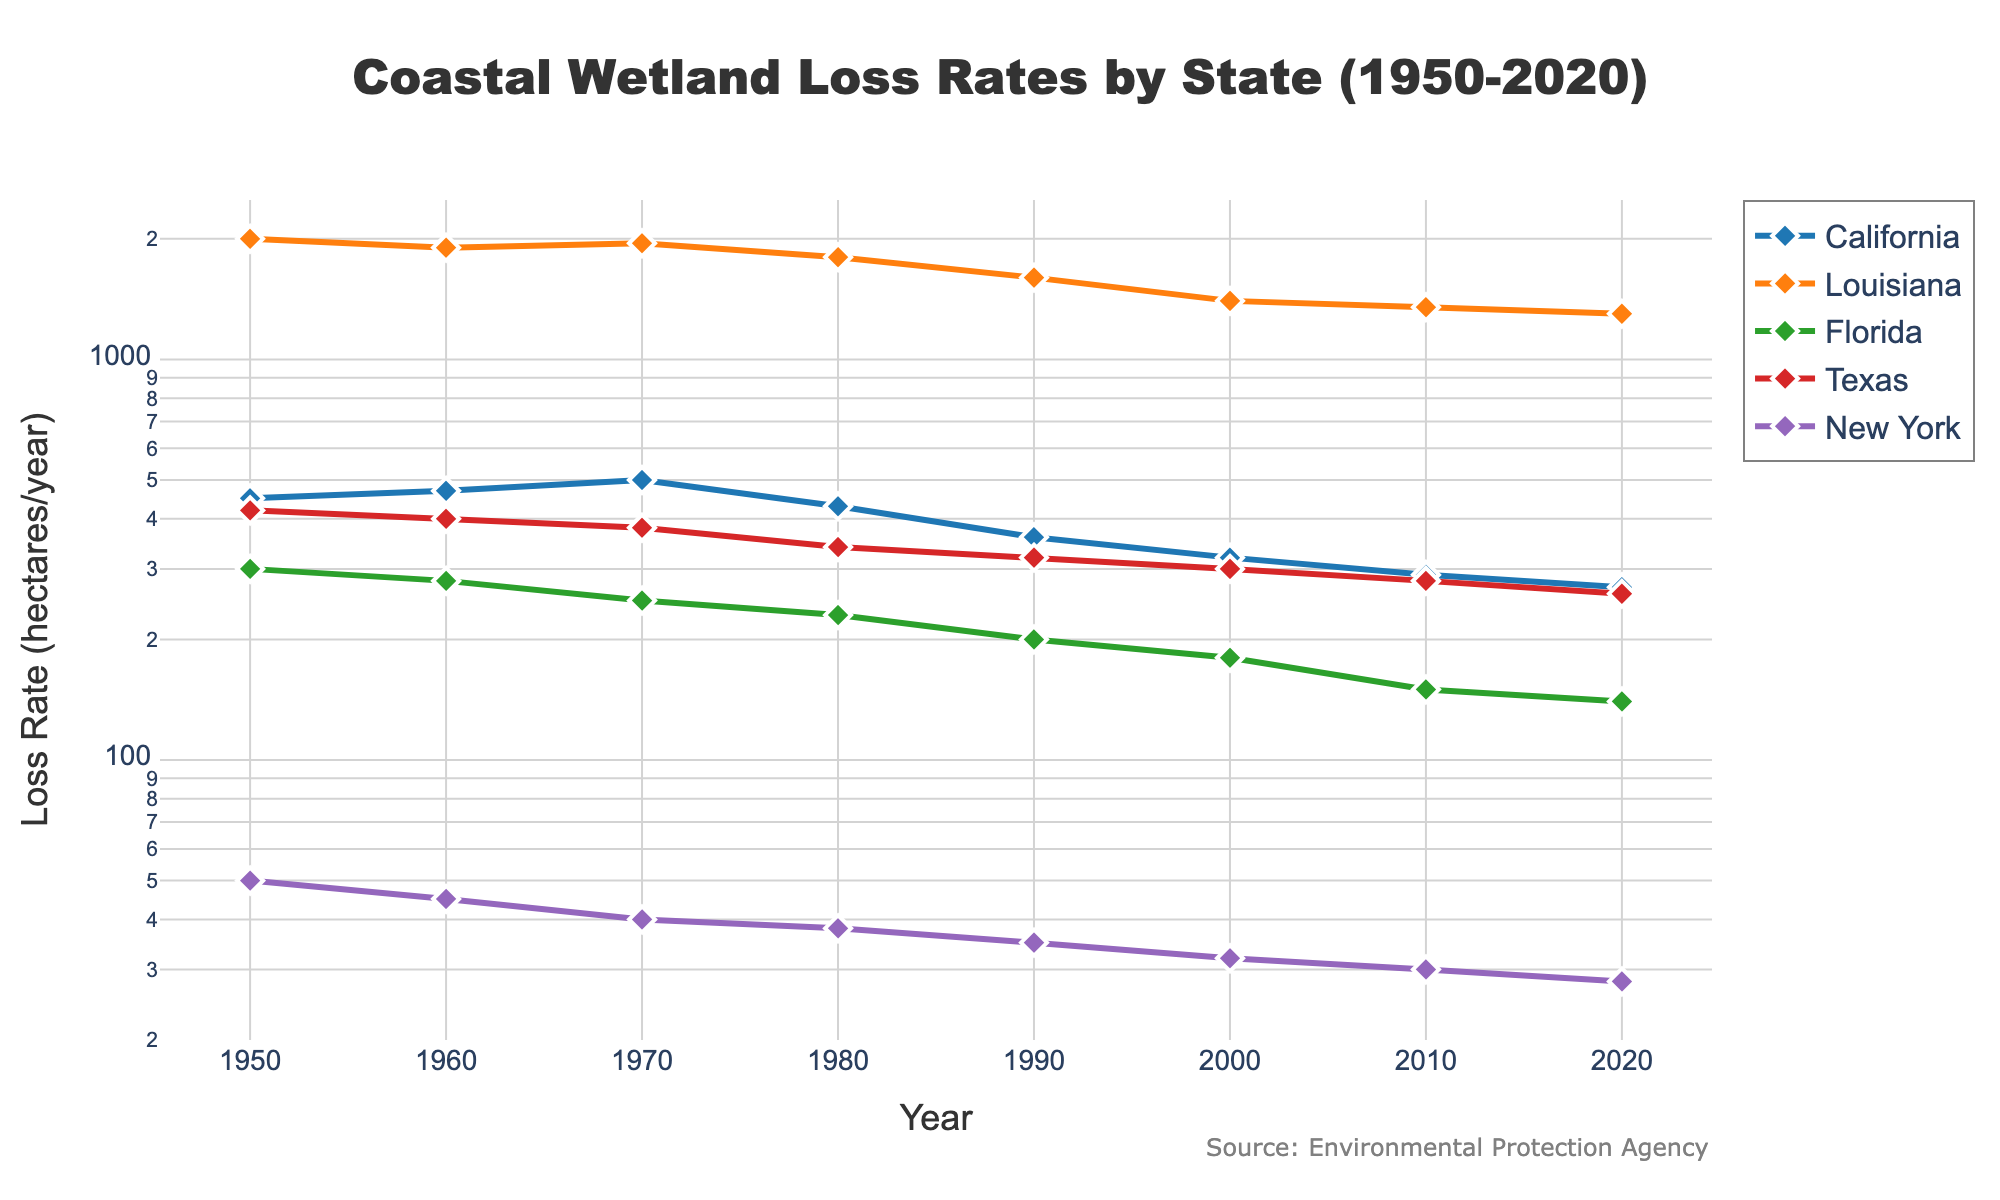What is the loss rate for California in 2020? Look for the data point representing California in the year 2020 and identify the corresponding y-axis value.
Answer: 270 hectares/year Which state had the highest initial wetland loss rate in 1950? Compare the data points for 1950 for all the states and identify the one with the highest value on the y-axis.
Answer: Louisiana How has Louisiana's loss rate changed from 1950 to 2020? Find the data points for Louisiana in 1950 and 2020 and compute the difference between these two values.
Answer: Decreased by 700 hectares/year (2000 - 1300) Which state's wetland loss rate has decreased the most from 1950 to 2020? Calculate the difference in loss rate from 1950 to 2020 for each state and identify the state with the highest decrease.
Answer: Louisiana (700 hectares/year) How do the trends of wetland loss rates from 1950 to 2020 compare between California and Texas? Analyze the graph's lines for both California and Texas from 1950 to 2020 and compare their slopes and change patterns.
Answer: Both show a decreasing trend, but Texas's rate is steadier, while California's decrease is more pronounced after 1970 What is the average loss rate in 2020 across all states? Locate the values for all states in 2020, sum them, and divide by the number of states.
Answer: 399.6 hectares/year Which state had the largest loss rate in the 1980s? Review data points for each state in 1980 and find the one with the highest value.
Answer: Louisiana Between 1970 and 1990, which state saw the smallest decrease in loss rate? For each state, calculate the loss rate difference between 1970 and 1990 and identify the smallest decrease.
Answer: New York (5 hectares/year) Describe the trend in wetland loss rates in New York from 1950 to 2020. Track the line corresponding to New York across the years and summarize its general direction and changes.
Answer: Gradual decrease Which state had the lowest loss rate in 2020? Compare the data points of all states in the year 2020 and identify the lowest value.
Answer: New York 